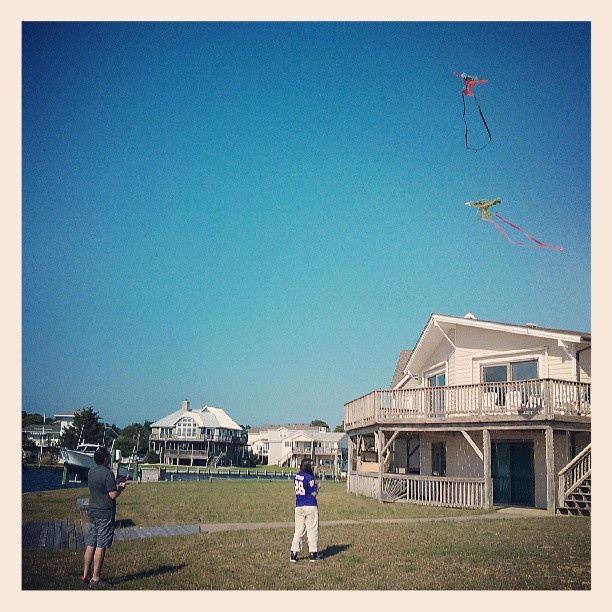Describe the objects in this image and their specific colors. I can see people in white, black, gray, and darkblue tones, people in ivory, lightgray, gray, and navy tones, boat in white, black, gray, darkgray, and lightgray tones, kite in ivory, gray, darkgray, and tan tones, and kite in white, gray, teal, and navy tones in this image. 